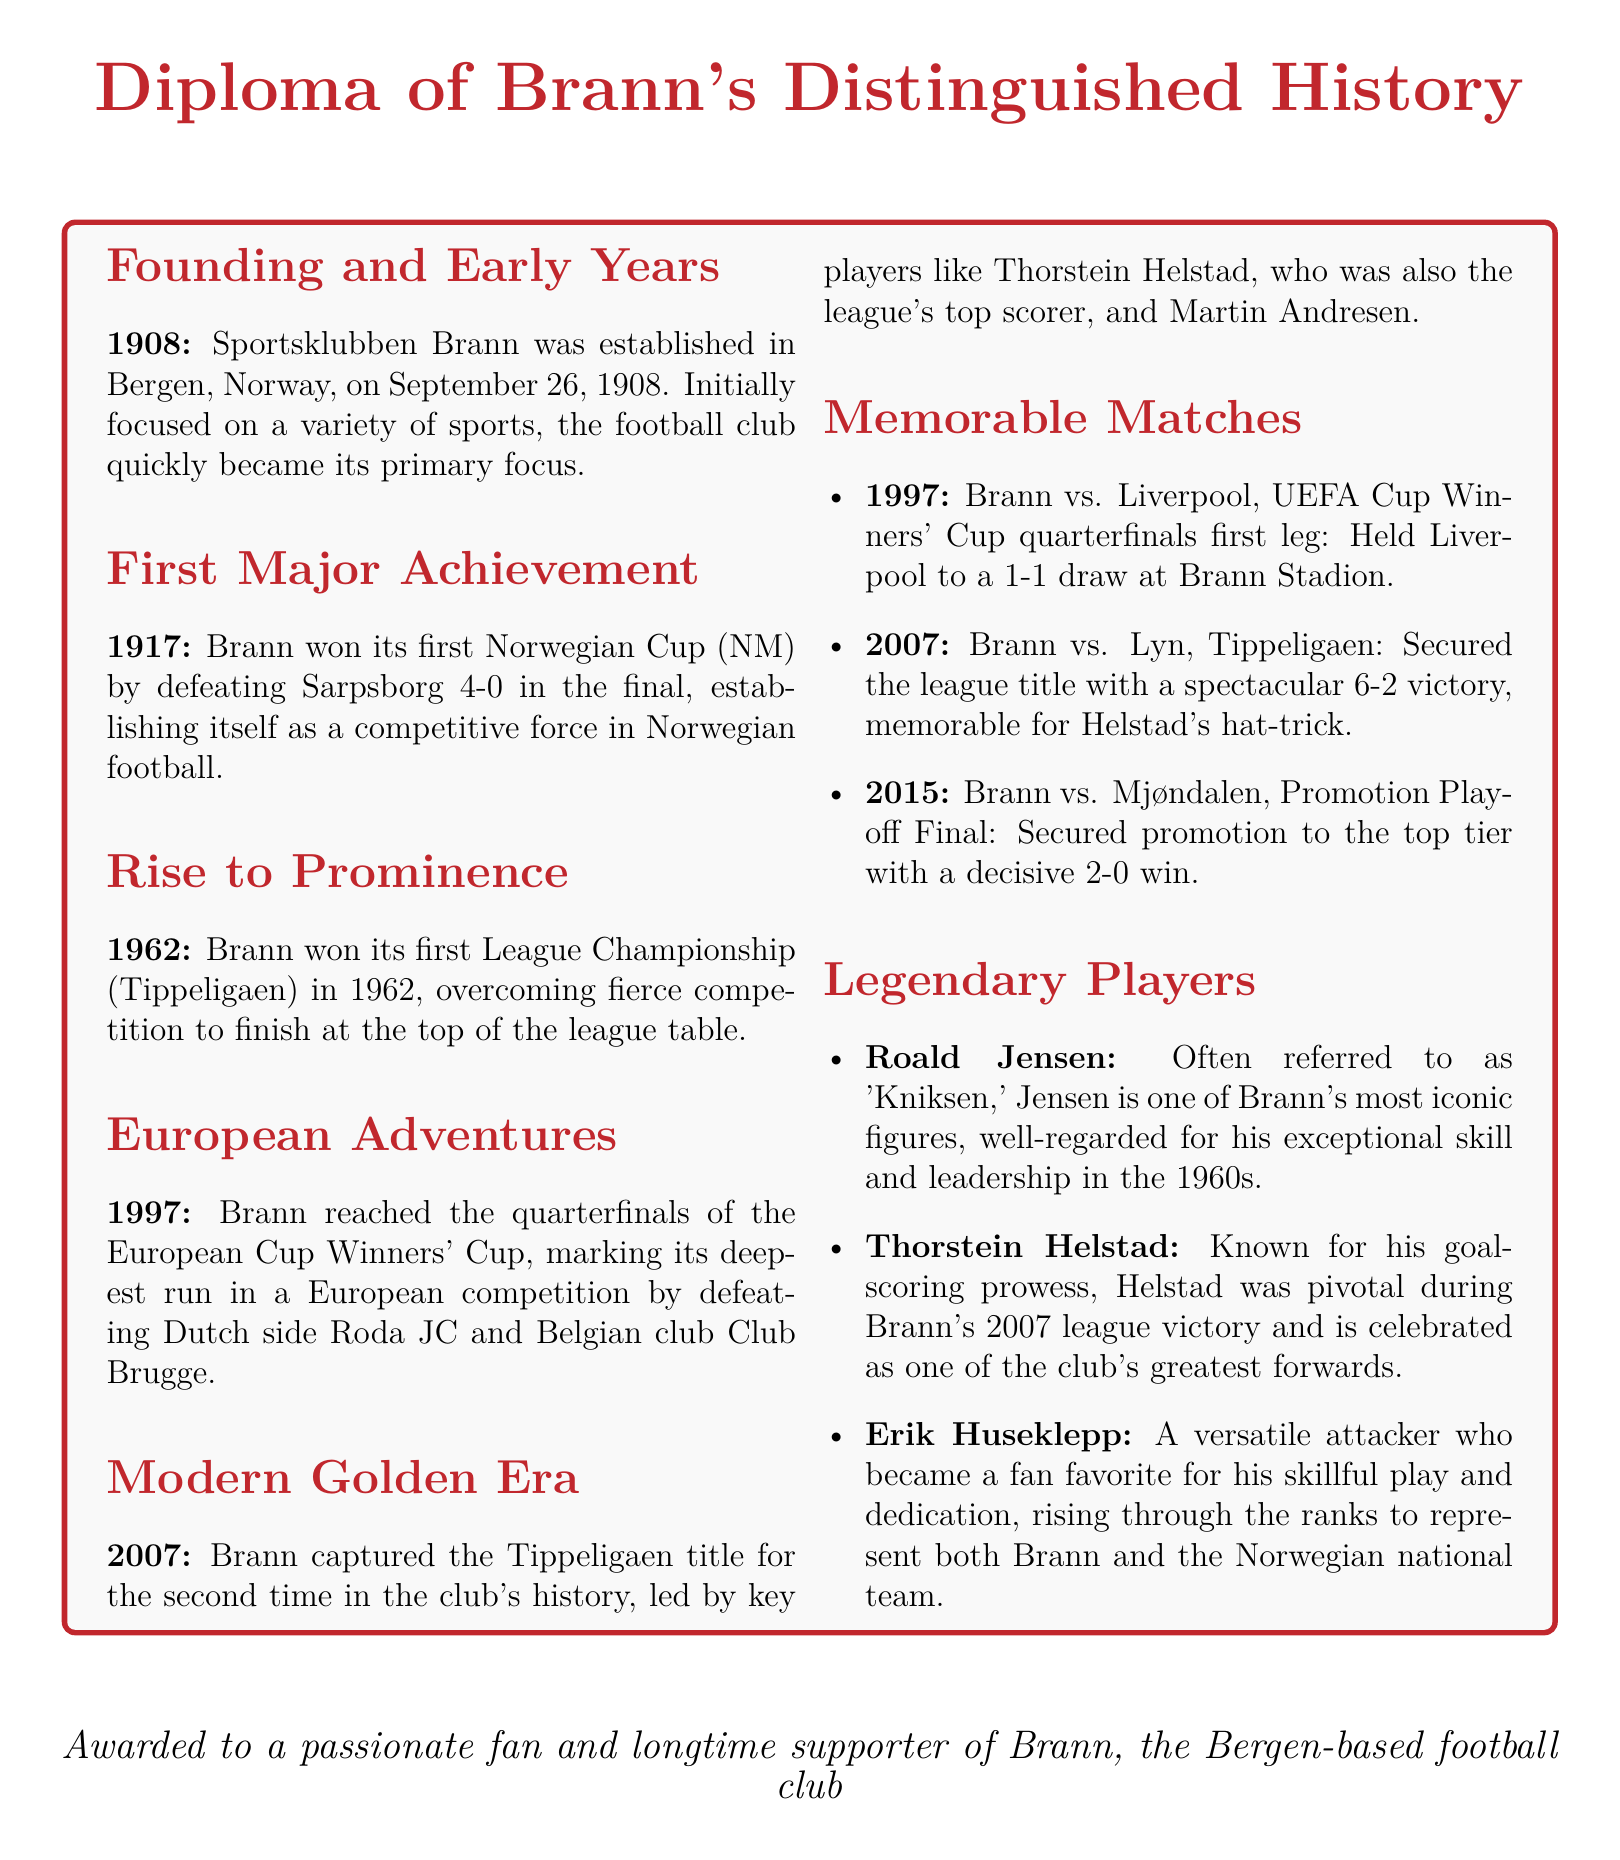what year was Brann founded? The founding year of Brann is mentioned in the document under "Founding and Early Years."
Answer: 1908 who did Brann defeat to win its first Norwegian Cup? The document states that Brann won its first Norwegian Cup by defeating Sarpsborg.
Answer: Sarpsborg what was significant about the year 1962 for Brann? The document highlights that Brann won its first League Championship in 1962, marking a rise to prominence.
Answer: First League Championship which European competition did Brann reach the quarterfinals in? The document specifies that Brann reached the quarterfinals of the European Cup Winners' Cup.
Answer: European Cup Winners' Cup who was the top scorer for Brann in 2007? The document indicates that Thorstein Helstad was the league's top scorer in Brann's 2007 victory.
Answer: Thorstein Helstad what memorable match secured Brann's promotion in 2015? The document notes that Brann secured promotion by winning the Promotion Playoff Final against Mjøndalen.
Answer: Mjøndalen who is referred to as 'Kniksen'? The document identifies Roald Jensen as 'Kniksen,' an iconic figure for Brann.
Answer: Roald Jensen what color is associated with Brann in the document? The document uses specific color definitions for Brann's branding, primarily indicated as 'brannred.'
Answer: brannred 